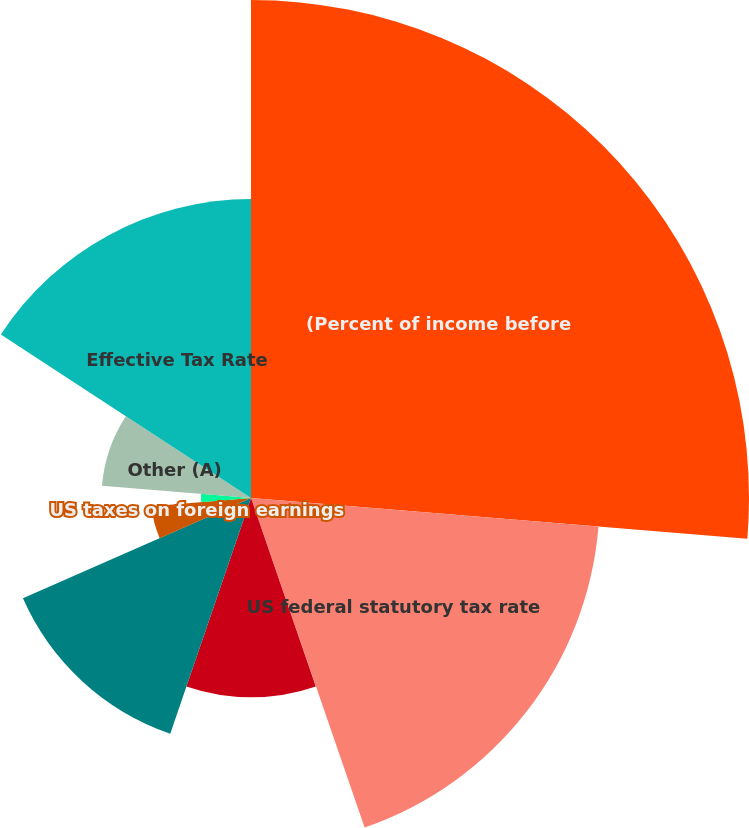Convert chart. <chart><loc_0><loc_0><loc_500><loc_500><pie_chart><fcel>(Percent of income before<fcel>US federal statutory tax rate<fcel>State taxes net of federal<fcel>Income from equity affiliates<fcel>Foreign tax differentials<fcel>US taxes on foreign earnings<fcel>Domestic production activities<fcel>Other (A)<fcel>Effective Tax Rate<nl><fcel>26.31%<fcel>18.42%<fcel>0.01%<fcel>10.53%<fcel>13.16%<fcel>5.27%<fcel>2.64%<fcel>7.9%<fcel>15.79%<nl></chart> 